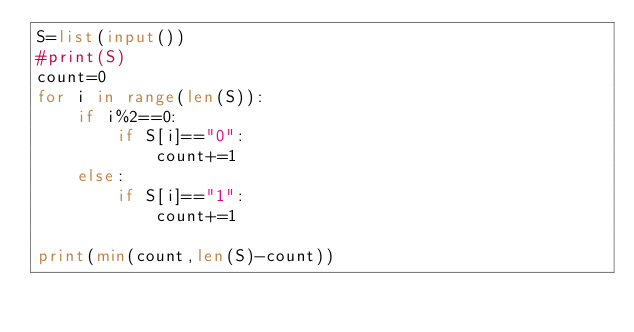Convert code to text. <code><loc_0><loc_0><loc_500><loc_500><_Python_>S=list(input())
#print(S)
count=0
for i in range(len(S)):
    if i%2==0:
        if S[i]=="0":
            count+=1
    else:
        if S[i]=="1":
            count+=1

print(min(count,len(S)-count))   </code> 